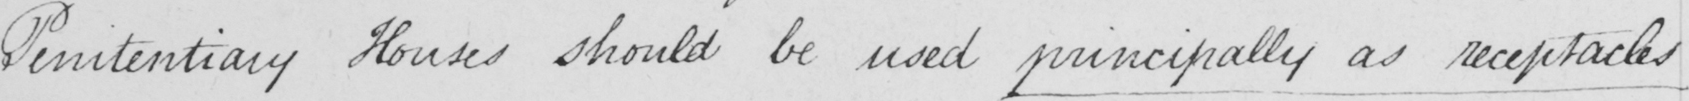Please provide the text content of this handwritten line. Penitentiary Houses should be used principally as receptacles 